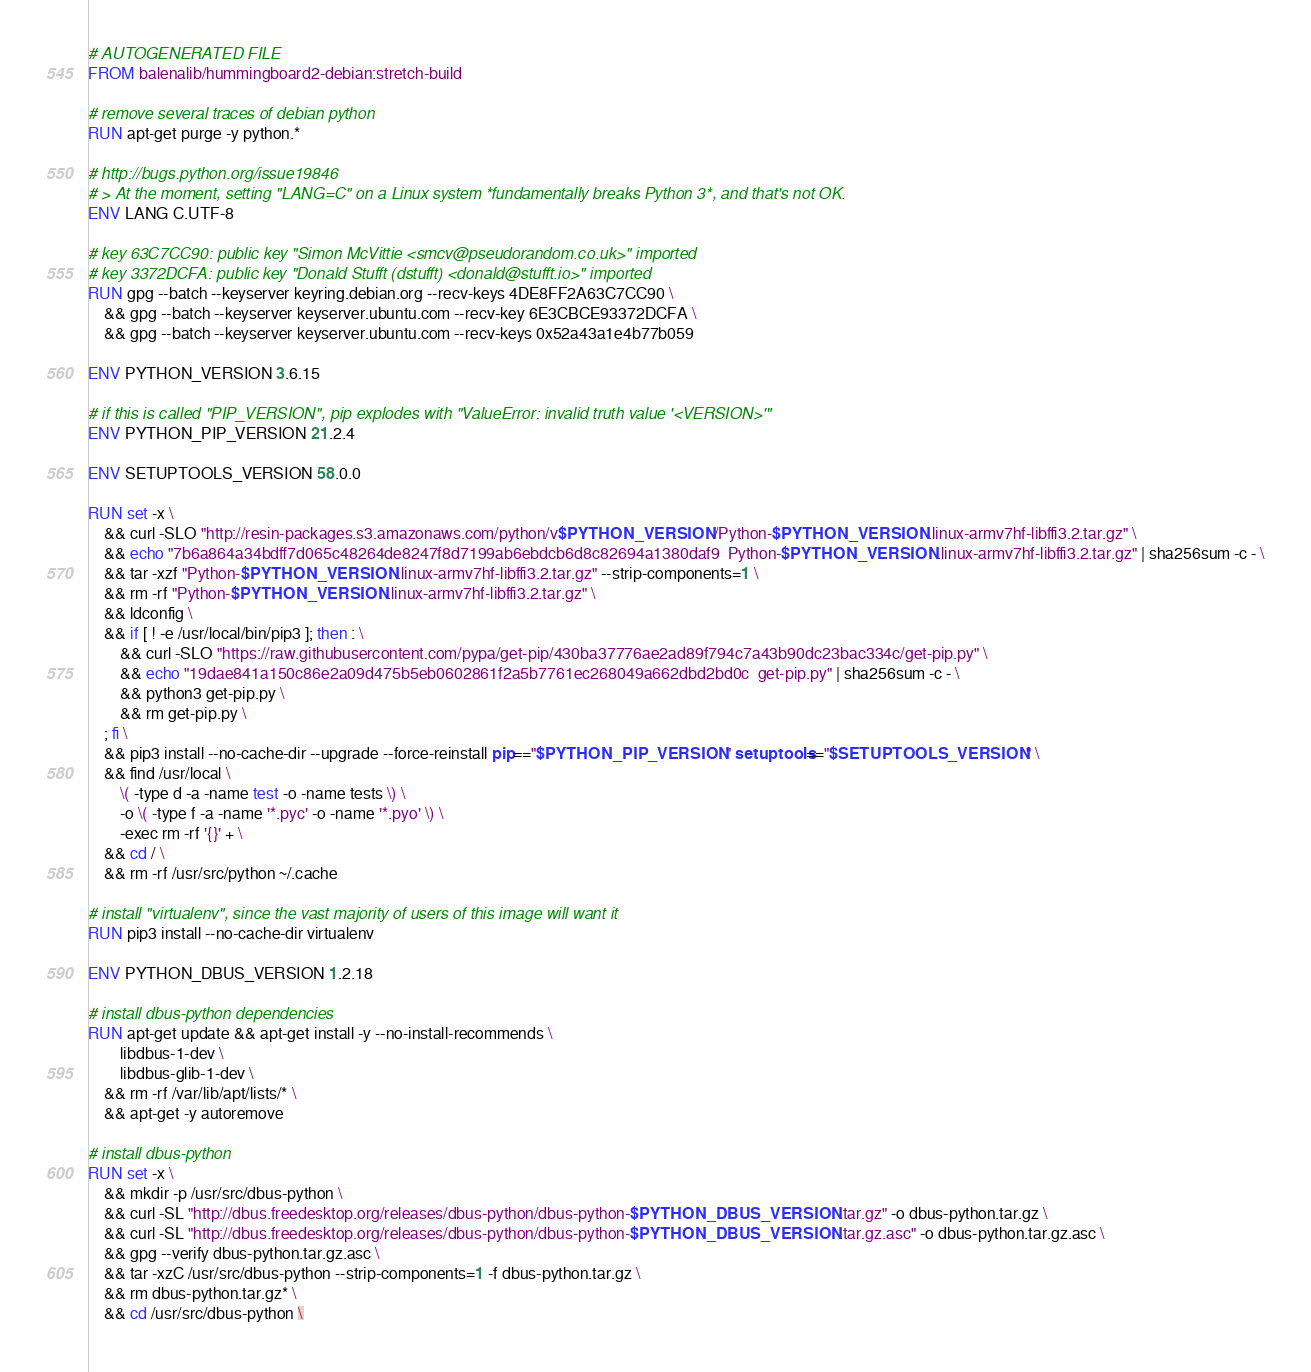<code> <loc_0><loc_0><loc_500><loc_500><_Dockerfile_># AUTOGENERATED FILE
FROM balenalib/hummingboard2-debian:stretch-build

# remove several traces of debian python
RUN apt-get purge -y python.*

# http://bugs.python.org/issue19846
# > At the moment, setting "LANG=C" on a Linux system *fundamentally breaks Python 3*, and that's not OK.
ENV LANG C.UTF-8

# key 63C7CC90: public key "Simon McVittie <smcv@pseudorandom.co.uk>" imported
# key 3372DCFA: public key "Donald Stufft (dstufft) <donald@stufft.io>" imported
RUN gpg --batch --keyserver keyring.debian.org --recv-keys 4DE8FF2A63C7CC90 \
	&& gpg --batch --keyserver keyserver.ubuntu.com --recv-key 6E3CBCE93372DCFA \
	&& gpg --batch --keyserver keyserver.ubuntu.com --recv-keys 0x52a43a1e4b77b059

ENV PYTHON_VERSION 3.6.15

# if this is called "PIP_VERSION", pip explodes with "ValueError: invalid truth value '<VERSION>'"
ENV PYTHON_PIP_VERSION 21.2.4

ENV SETUPTOOLS_VERSION 58.0.0

RUN set -x \
	&& curl -SLO "http://resin-packages.s3.amazonaws.com/python/v$PYTHON_VERSION/Python-$PYTHON_VERSION.linux-armv7hf-libffi3.2.tar.gz" \
	&& echo "7b6a864a34bdff7d065c48264de8247f8d7199ab6ebdcb6d8c82694a1380daf9  Python-$PYTHON_VERSION.linux-armv7hf-libffi3.2.tar.gz" | sha256sum -c - \
	&& tar -xzf "Python-$PYTHON_VERSION.linux-armv7hf-libffi3.2.tar.gz" --strip-components=1 \
	&& rm -rf "Python-$PYTHON_VERSION.linux-armv7hf-libffi3.2.tar.gz" \
	&& ldconfig \
	&& if [ ! -e /usr/local/bin/pip3 ]; then : \
		&& curl -SLO "https://raw.githubusercontent.com/pypa/get-pip/430ba37776ae2ad89f794c7a43b90dc23bac334c/get-pip.py" \
		&& echo "19dae841a150c86e2a09d475b5eb0602861f2a5b7761ec268049a662dbd2bd0c  get-pip.py" | sha256sum -c - \
		&& python3 get-pip.py \
		&& rm get-pip.py \
	; fi \
	&& pip3 install --no-cache-dir --upgrade --force-reinstall pip=="$PYTHON_PIP_VERSION" setuptools=="$SETUPTOOLS_VERSION" \
	&& find /usr/local \
		\( -type d -a -name test -o -name tests \) \
		-o \( -type f -a -name '*.pyc' -o -name '*.pyo' \) \
		-exec rm -rf '{}' + \
	&& cd / \
	&& rm -rf /usr/src/python ~/.cache

# install "virtualenv", since the vast majority of users of this image will want it
RUN pip3 install --no-cache-dir virtualenv

ENV PYTHON_DBUS_VERSION 1.2.18

# install dbus-python dependencies 
RUN apt-get update && apt-get install -y --no-install-recommends \
		libdbus-1-dev \
		libdbus-glib-1-dev \
	&& rm -rf /var/lib/apt/lists/* \
	&& apt-get -y autoremove

# install dbus-python
RUN set -x \
	&& mkdir -p /usr/src/dbus-python \
	&& curl -SL "http://dbus.freedesktop.org/releases/dbus-python/dbus-python-$PYTHON_DBUS_VERSION.tar.gz" -o dbus-python.tar.gz \
	&& curl -SL "http://dbus.freedesktop.org/releases/dbus-python/dbus-python-$PYTHON_DBUS_VERSION.tar.gz.asc" -o dbus-python.tar.gz.asc \
	&& gpg --verify dbus-python.tar.gz.asc \
	&& tar -xzC /usr/src/dbus-python --strip-components=1 -f dbus-python.tar.gz \
	&& rm dbus-python.tar.gz* \
	&& cd /usr/src/dbus-python \</code> 